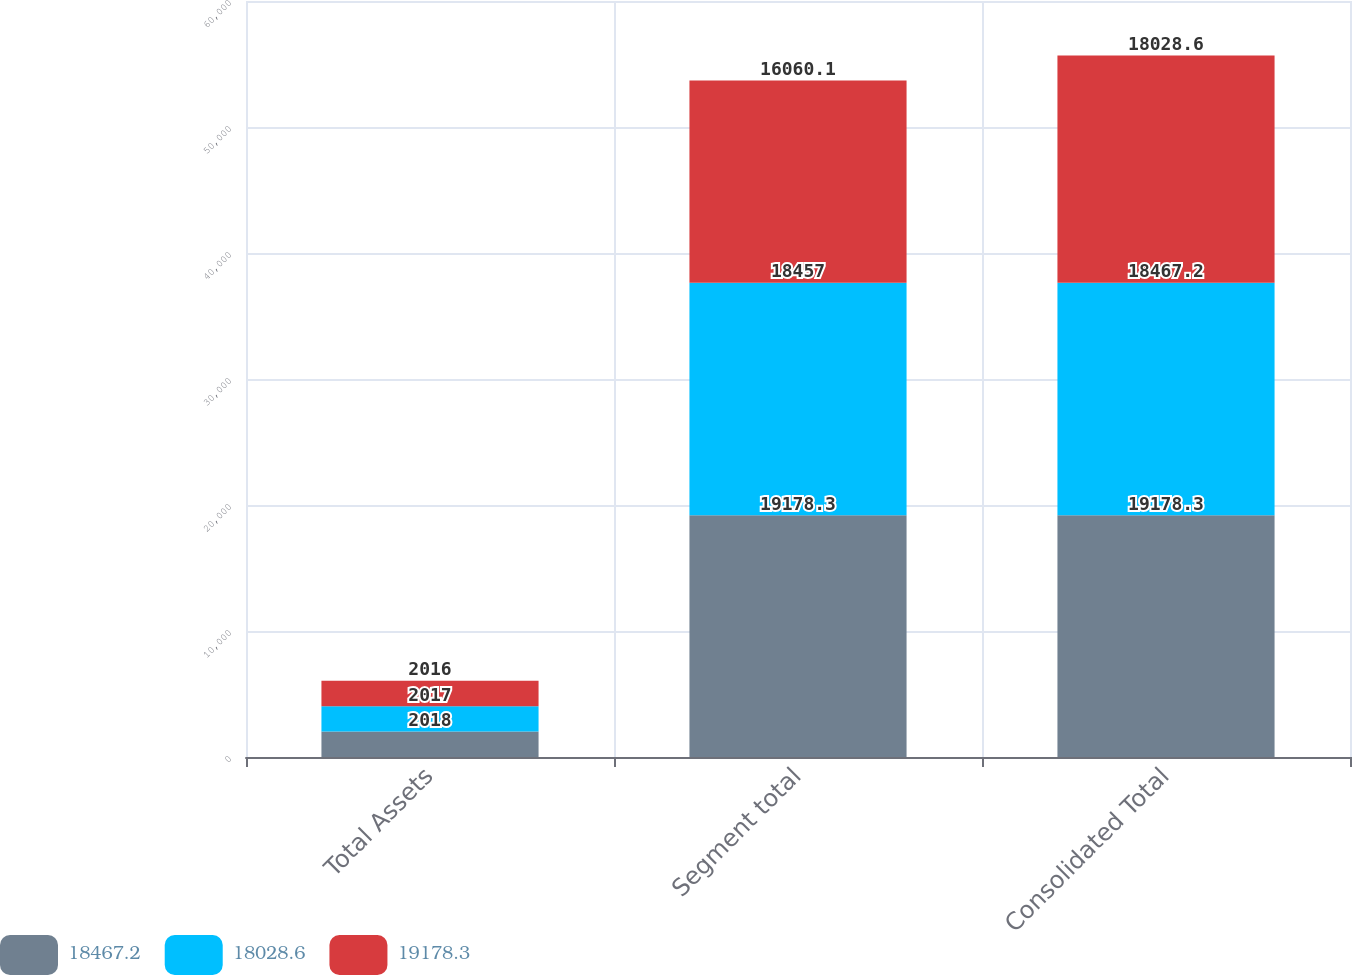Convert chart to OTSL. <chart><loc_0><loc_0><loc_500><loc_500><stacked_bar_chart><ecel><fcel>Total Assets<fcel>Segment total<fcel>Consolidated Total<nl><fcel>18467.2<fcel>2018<fcel>19178.3<fcel>19178.3<nl><fcel>18028.6<fcel>2017<fcel>18457<fcel>18467.2<nl><fcel>19178.3<fcel>2016<fcel>16060.1<fcel>18028.6<nl></chart> 